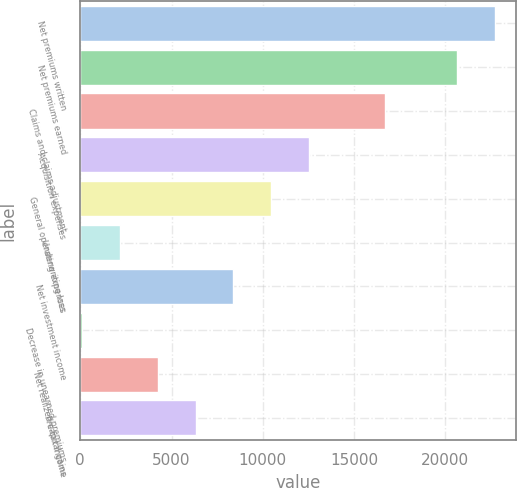Convert chart. <chart><loc_0><loc_0><loc_500><loc_500><bar_chart><fcel>Net premiums written<fcel>Net premiums earned<fcel>Claims and claims adjustment<fcel>Acquisition expenses<fcel>General operating expenses<fcel>Underwriting loss<fcel>Net investment income<fcel>Decrease in unearned premiums<fcel>Net realized capital gains<fcel>Pre-tax income<nl><fcel>22711.9<fcel>20637<fcel>16692.2<fcel>12542.4<fcel>10467.5<fcel>2167.9<fcel>8392.6<fcel>93<fcel>4242.8<fcel>6317.7<nl></chart> 